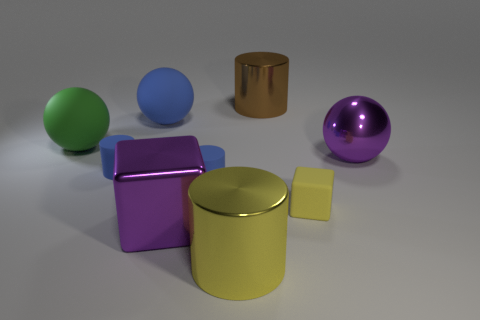Subtract all purple spheres. How many spheres are left? 2 Subtract all large yellow shiny cylinders. How many cylinders are left? 3 Subtract 3 cylinders. How many cylinders are left? 1 Subtract all yellow cylinders. Subtract all yellow blocks. How many cylinders are left? 3 Subtract all purple cylinders. How many green balls are left? 1 Subtract all yellow cylinders. Subtract all blue balls. How many objects are left? 7 Add 3 brown cylinders. How many brown cylinders are left? 4 Add 5 big cubes. How many big cubes exist? 6 Add 1 large blue blocks. How many objects exist? 10 Subtract 0 cyan spheres. How many objects are left? 9 